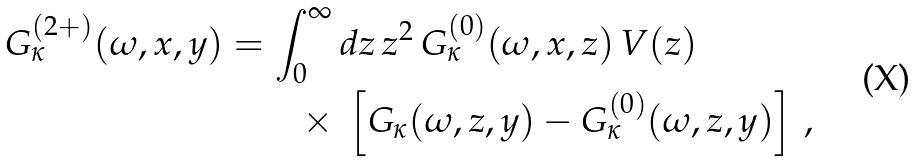Convert formula to latex. <formula><loc_0><loc_0><loc_500><loc_500>G ^ { ( 2 + ) } _ { \kappa } ( \omega , x , y ) = \int _ { 0 } ^ { \infty } & \, d z \, z ^ { 2 } \, G ^ { ( 0 ) } _ { \kappa } ( \omega , x , z ) \, V ( z ) \, \\ \times & \ \left [ G _ { \kappa } ( \omega , z , y ) - G ^ { ( 0 ) } _ { \kappa } ( \omega , z , y ) \right ] \, ,</formula> 